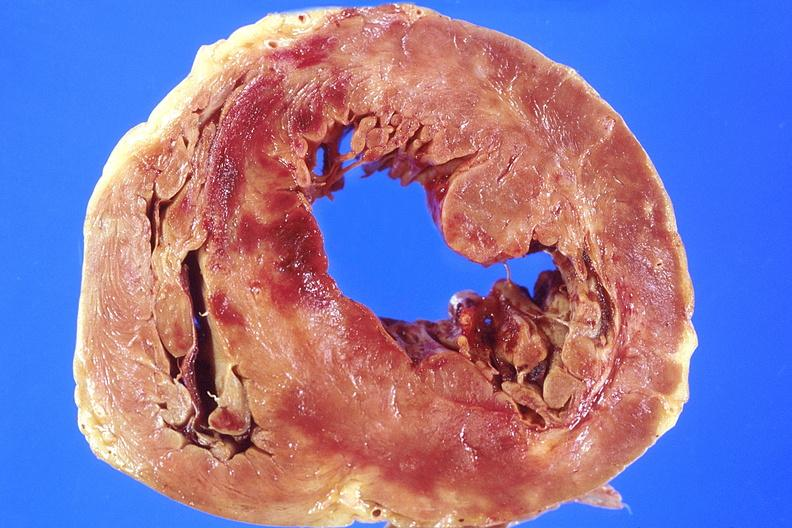what does this image show?
Answer the question using a single word or phrase. Heart 